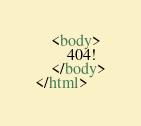Convert code to text. <code><loc_0><loc_0><loc_500><loc_500><_HTML_>    <body>
        404!
    </body>
</html>
</code> 